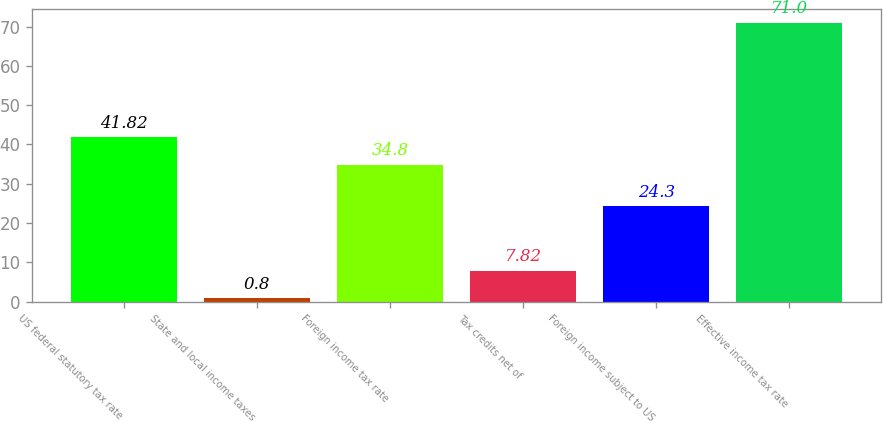Convert chart to OTSL. <chart><loc_0><loc_0><loc_500><loc_500><bar_chart><fcel>US federal statutory tax rate<fcel>State and local income taxes<fcel>Foreign income tax rate<fcel>Tax credits net of<fcel>Foreign income subject to US<fcel>Effective income tax rate<nl><fcel>41.82<fcel>0.8<fcel>34.8<fcel>7.82<fcel>24.3<fcel>71<nl></chart> 